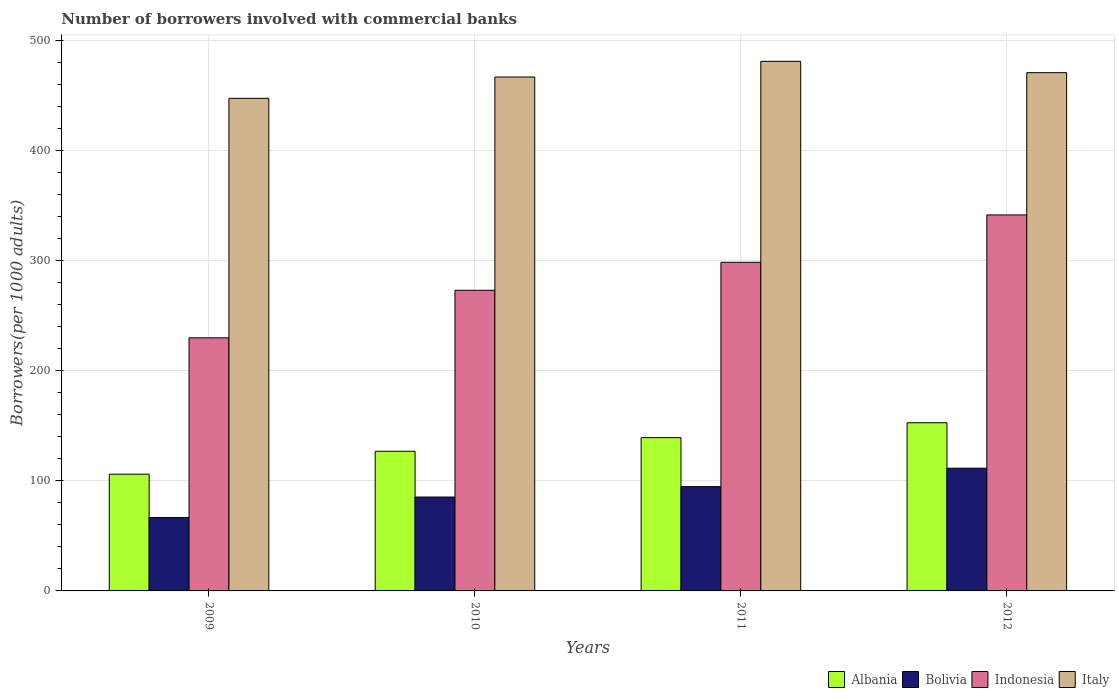How many different coloured bars are there?
Offer a very short reply. 4. Are the number of bars per tick equal to the number of legend labels?
Keep it short and to the point. Yes. Are the number of bars on each tick of the X-axis equal?
Your response must be concise. Yes. What is the label of the 1st group of bars from the left?
Provide a succinct answer. 2009. In how many cases, is the number of bars for a given year not equal to the number of legend labels?
Give a very brief answer. 0. What is the number of borrowers involved with commercial banks in Indonesia in 2010?
Make the answer very short. 273.1. Across all years, what is the maximum number of borrowers involved with commercial banks in Bolivia?
Provide a short and direct response. 111.49. Across all years, what is the minimum number of borrowers involved with commercial banks in Italy?
Provide a succinct answer. 447.49. In which year was the number of borrowers involved with commercial banks in Bolivia maximum?
Your answer should be very brief. 2012. What is the total number of borrowers involved with commercial banks in Bolivia in the graph?
Offer a terse response. 358.18. What is the difference between the number of borrowers involved with commercial banks in Indonesia in 2011 and that in 2012?
Provide a short and direct response. -43.06. What is the difference between the number of borrowers involved with commercial banks in Indonesia in 2011 and the number of borrowers involved with commercial banks in Bolivia in 2012?
Give a very brief answer. 187.02. What is the average number of borrowers involved with commercial banks in Italy per year?
Your response must be concise. 466.55. In the year 2012, what is the difference between the number of borrowers involved with commercial banks in Italy and number of borrowers involved with commercial banks in Bolivia?
Offer a very short reply. 359.3. In how many years, is the number of borrowers involved with commercial banks in Italy greater than 40?
Keep it short and to the point. 4. What is the ratio of the number of borrowers involved with commercial banks in Bolivia in 2009 to that in 2011?
Provide a succinct answer. 0.7. Is the number of borrowers involved with commercial banks in Bolivia in 2009 less than that in 2011?
Provide a succinct answer. Yes. What is the difference between the highest and the second highest number of borrowers involved with commercial banks in Italy?
Make the answer very short. 10.28. What is the difference between the highest and the lowest number of borrowers involved with commercial banks in Bolivia?
Your answer should be very brief. 44.81. Is it the case that in every year, the sum of the number of borrowers involved with commercial banks in Italy and number of borrowers involved with commercial banks in Bolivia is greater than the sum of number of borrowers involved with commercial banks in Albania and number of borrowers involved with commercial banks in Indonesia?
Offer a very short reply. Yes. What does the 2nd bar from the left in 2009 represents?
Give a very brief answer. Bolivia. What does the 1st bar from the right in 2012 represents?
Offer a terse response. Italy. Is it the case that in every year, the sum of the number of borrowers involved with commercial banks in Indonesia and number of borrowers involved with commercial banks in Italy is greater than the number of borrowers involved with commercial banks in Bolivia?
Your answer should be very brief. Yes. How many bars are there?
Provide a succinct answer. 16. Are the values on the major ticks of Y-axis written in scientific E-notation?
Your response must be concise. No. Does the graph contain any zero values?
Provide a succinct answer. No. Does the graph contain grids?
Your answer should be very brief. Yes. Where does the legend appear in the graph?
Give a very brief answer. Bottom right. How many legend labels are there?
Make the answer very short. 4. What is the title of the graph?
Ensure brevity in your answer.  Number of borrowers involved with commercial banks. Does "St. Kitts and Nevis" appear as one of the legend labels in the graph?
Your answer should be very brief. No. What is the label or title of the X-axis?
Your response must be concise. Years. What is the label or title of the Y-axis?
Your answer should be very brief. Borrowers(per 1000 adults). What is the Borrowers(per 1000 adults) of Albania in 2009?
Keep it short and to the point. 106.05. What is the Borrowers(per 1000 adults) in Bolivia in 2009?
Provide a short and direct response. 66.68. What is the Borrowers(per 1000 adults) in Indonesia in 2009?
Keep it short and to the point. 229.92. What is the Borrowers(per 1000 adults) of Italy in 2009?
Your answer should be very brief. 447.49. What is the Borrowers(per 1000 adults) of Albania in 2010?
Provide a short and direct response. 126.87. What is the Borrowers(per 1000 adults) of Bolivia in 2010?
Ensure brevity in your answer.  85.29. What is the Borrowers(per 1000 adults) in Indonesia in 2010?
Your response must be concise. 273.1. What is the Borrowers(per 1000 adults) of Italy in 2010?
Give a very brief answer. 466.85. What is the Borrowers(per 1000 adults) in Albania in 2011?
Offer a terse response. 139.27. What is the Borrowers(per 1000 adults) of Bolivia in 2011?
Offer a terse response. 94.73. What is the Borrowers(per 1000 adults) in Indonesia in 2011?
Keep it short and to the point. 298.51. What is the Borrowers(per 1000 adults) in Italy in 2011?
Offer a terse response. 481.07. What is the Borrowers(per 1000 adults) of Albania in 2012?
Keep it short and to the point. 152.78. What is the Borrowers(per 1000 adults) in Bolivia in 2012?
Keep it short and to the point. 111.49. What is the Borrowers(per 1000 adults) of Indonesia in 2012?
Provide a short and direct response. 341.57. What is the Borrowers(per 1000 adults) in Italy in 2012?
Your answer should be very brief. 470.79. Across all years, what is the maximum Borrowers(per 1000 adults) of Albania?
Your answer should be very brief. 152.78. Across all years, what is the maximum Borrowers(per 1000 adults) of Bolivia?
Give a very brief answer. 111.49. Across all years, what is the maximum Borrowers(per 1000 adults) in Indonesia?
Ensure brevity in your answer.  341.57. Across all years, what is the maximum Borrowers(per 1000 adults) in Italy?
Your answer should be compact. 481.07. Across all years, what is the minimum Borrowers(per 1000 adults) in Albania?
Keep it short and to the point. 106.05. Across all years, what is the minimum Borrowers(per 1000 adults) of Bolivia?
Offer a terse response. 66.68. Across all years, what is the minimum Borrowers(per 1000 adults) in Indonesia?
Your answer should be compact. 229.92. Across all years, what is the minimum Borrowers(per 1000 adults) in Italy?
Offer a terse response. 447.49. What is the total Borrowers(per 1000 adults) in Albania in the graph?
Offer a terse response. 524.96. What is the total Borrowers(per 1000 adults) in Bolivia in the graph?
Ensure brevity in your answer.  358.18. What is the total Borrowers(per 1000 adults) of Indonesia in the graph?
Your answer should be very brief. 1143.09. What is the total Borrowers(per 1000 adults) in Italy in the graph?
Offer a terse response. 1866.2. What is the difference between the Borrowers(per 1000 adults) in Albania in 2009 and that in 2010?
Your answer should be very brief. -20.82. What is the difference between the Borrowers(per 1000 adults) in Bolivia in 2009 and that in 2010?
Your answer should be compact. -18.61. What is the difference between the Borrowers(per 1000 adults) in Indonesia in 2009 and that in 2010?
Your answer should be very brief. -43.19. What is the difference between the Borrowers(per 1000 adults) of Italy in 2009 and that in 2010?
Give a very brief answer. -19.36. What is the difference between the Borrowers(per 1000 adults) in Albania in 2009 and that in 2011?
Your answer should be compact. -33.22. What is the difference between the Borrowers(per 1000 adults) in Bolivia in 2009 and that in 2011?
Your response must be concise. -28.05. What is the difference between the Borrowers(per 1000 adults) of Indonesia in 2009 and that in 2011?
Offer a terse response. -68.59. What is the difference between the Borrowers(per 1000 adults) of Italy in 2009 and that in 2011?
Offer a very short reply. -33.58. What is the difference between the Borrowers(per 1000 adults) of Albania in 2009 and that in 2012?
Ensure brevity in your answer.  -46.73. What is the difference between the Borrowers(per 1000 adults) of Bolivia in 2009 and that in 2012?
Offer a terse response. -44.81. What is the difference between the Borrowers(per 1000 adults) in Indonesia in 2009 and that in 2012?
Provide a succinct answer. -111.65. What is the difference between the Borrowers(per 1000 adults) of Italy in 2009 and that in 2012?
Your response must be concise. -23.3. What is the difference between the Borrowers(per 1000 adults) in Albania in 2010 and that in 2011?
Provide a succinct answer. -12.4. What is the difference between the Borrowers(per 1000 adults) in Bolivia in 2010 and that in 2011?
Ensure brevity in your answer.  -9.45. What is the difference between the Borrowers(per 1000 adults) in Indonesia in 2010 and that in 2011?
Ensure brevity in your answer.  -25.4. What is the difference between the Borrowers(per 1000 adults) of Italy in 2010 and that in 2011?
Ensure brevity in your answer.  -14.22. What is the difference between the Borrowers(per 1000 adults) in Albania in 2010 and that in 2012?
Your response must be concise. -25.91. What is the difference between the Borrowers(per 1000 adults) in Bolivia in 2010 and that in 2012?
Ensure brevity in your answer.  -26.2. What is the difference between the Borrowers(per 1000 adults) of Indonesia in 2010 and that in 2012?
Keep it short and to the point. -68.47. What is the difference between the Borrowers(per 1000 adults) of Italy in 2010 and that in 2012?
Offer a terse response. -3.94. What is the difference between the Borrowers(per 1000 adults) in Albania in 2011 and that in 2012?
Offer a terse response. -13.51. What is the difference between the Borrowers(per 1000 adults) in Bolivia in 2011 and that in 2012?
Your answer should be very brief. -16.75. What is the difference between the Borrowers(per 1000 adults) in Indonesia in 2011 and that in 2012?
Keep it short and to the point. -43.06. What is the difference between the Borrowers(per 1000 adults) of Italy in 2011 and that in 2012?
Offer a terse response. 10.28. What is the difference between the Borrowers(per 1000 adults) of Albania in 2009 and the Borrowers(per 1000 adults) of Bolivia in 2010?
Make the answer very short. 20.76. What is the difference between the Borrowers(per 1000 adults) in Albania in 2009 and the Borrowers(per 1000 adults) in Indonesia in 2010?
Your response must be concise. -167.05. What is the difference between the Borrowers(per 1000 adults) in Albania in 2009 and the Borrowers(per 1000 adults) in Italy in 2010?
Offer a terse response. -360.8. What is the difference between the Borrowers(per 1000 adults) of Bolivia in 2009 and the Borrowers(per 1000 adults) of Indonesia in 2010?
Offer a very short reply. -206.42. What is the difference between the Borrowers(per 1000 adults) in Bolivia in 2009 and the Borrowers(per 1000 adults) in Italy in 2010?
Your answer should be very brief. -400.17. What is the difference between the Borrowers(per 1000 adults) in Indonesia in 2009 and the Borrowers(per 1000 adults) in Italy in 2010?
Make the answer very short. -236.93. What is the difference between the Borrowers(per 1000 adults) of Albania in 2009 and the Borrowers(per 1000 adults) of Bolivia in 2011?
Keep it short and to the point. 11.31. What is the difference between the Borrowers(per 1000 adults) in Albania in 2009 and the Borrowers(per 1000 adults) in Indonesia in 2011?
Your response must be concise. -192.46. What is the difference between the Borrowers(per 1000 adults) in Albania in 2009 and the Borrowers(per 1000 adults) in Italy in 2011?
Ensure brevity in your answer.  -375.02. What is the difference between the Borrowers(per 1000 adults) in Bolivia in 2009 and the Borrowers(per 1000 adults) in Indonesia in 2011?
Offer a very short reply. -231.83. What is the difference between the Borrowers(per 1000 adults) of Bolivia in 2009 and the Borrowers(per 1000 adults) of Italy in 2011?
Provide a succinct answer. -414.39. What is the difference between the Borrowers(per 1000 adults) of Indonesia in 2009 and the Borrowers(per 1000 adults) of Italy in 2011?
Keep it short and to the point. -251.15. What is the difference between the Borrowers(per 1000 adults) of Albania in 2009 and the Borrowers(per 1000 adults) of Bolivia in 2012?
Your answer should be compact. -5.44. What is the difference between the Borrowers(per 1000 adults) in Albania in 2009 and the Borrowers(per 1000 adults) in Indonesia in 2012?
Provide a succinct answer. -235.52. What is the difference between the Borrowers(per 1000 adults) in Albania in 2009 and the Borrowers(per 1000 adults) in Italy in 2012?
Your answer should be very brief. -364.74. What is the difference between the Borrowers(per 1000 adults) of Bolivia in 2009 and the Borrowers(per 1000 adults) of Indonesia in 2012?
Make the answer very short. -274.89. What is the difference between the Borrowers(per 1000 adults) of Bolivia in 2009 and the Borrowers(per 1000 adults) of Italy in 2012?
Your answer should be compact. -404.11. What is the difference between the Borrowers(per 1000 adults) in Indonesia in 2009 and the Borrowers(per 1000 adults) in Italy in 2012?
Your answer should be compact. -240.87. What is the difference between the Borrowers(per 1000 adults) of Albania in 2010 and the Borrowers(per 1000 adults) of Bolivia in 2011?
Make the answer very short. 32.13. What is the difference between the Borrowers(per 1000 adults) in Albania in 2010 and the Borrowers(per 1000 adults) in Indonesia in 2011?
Offer a terse response. -171.64. What is the difference between the Borrowers(per 1000 adults) of Albania in 2010 and the Borrowers(per 1000 adults) of Italy in 2011?
Give a very brief answer. -354.2. What is the difference between the Borrowers(per 1000 adults) of Bolivia in 2010 and the Borrowers(per 1000 adults) of Indonesia in 2011?
Your answer should be compact. -213.22. What is the difference between the Borrowers(per 1000 adults) in Bolivia in 2010 and the Borrowers(per 1000 adults) in Italy in 2011?
Provide a succinct answer. -395.78. What is the difference between the Borrowers(per 1000 adults) in Indonesia in 2010 and the Borrowers(per 1000 adults) in Italy in 2011?
Keep it short and to the point. -207.97. What is the difference between the Borrowers(per 1000 adults) in Albania in 2010 and the Borrowers(per 1000 adults) in Bolivia in 2012?
Provide a short and direct response. 15.38. What is the difference between the Borrowers(per 1000 adults) of Albania in 2010 and the Borrowers(per 1000 adults) of Indonesia in 2012?
Provide a short and direct response. -214.7. What is the difference between the Borrowers(per 1000 adults) in Albania in 2010 and the Borrowers(per 1000 adults) in Italy in 2012?
Give a very brief answer. -343.92. What is the difference between the Borrowers(per 1000 adults) of Bolivia in 2010 and the Borrowers(per 1000 adults) of Indonesia in 2012?
Your answer should be compact. -256.28. What is the difference between the Borrowers(per 1000 adults) in Bolivia in 2010 and the Borrowers(per 1000 adults) in Italy in 2012?
Ensure brevity in your answer.  -385.5. What is the difference between the Borrowers(per 1000 adults) in Indonesia in 2010 and the Borrowers(per 1000 adults) in Italy in 2012?
Your response must be concise. -197.69. What is the difference between the Borrowers(per 1000 adults) of Albania in 2011 and the Borrowers(per 1000 adults) of Bolivia in 2012?
Ensure brevity in your answer.  27.78. What is the difference between the Borrowers(per 1000 adults) of Albania in 2011 and the Borrowers(per 1000 adults) of Indonesia in 2012?
Offer a very short reply. -202.3. What is the difference between the Borrowers(per 1000 adults) in Albania in 2011 and the Borrowers(per 1000 adults) in Italy in 2012?
Keep it short and to the point. -331.52. What is the difference between the Borrowers(per 1000 adults) in Bolivia in 2011 and the Borrowers(per 1000 adults) in Indonesia in 2012?
Offer a very short reply. -246.84. What is the difference between the Borrowers(per 1000 adults) in Bolivia in 2011 and the Borrowers(per 1000 adults) in Italy in 2012?
Ensure brevity in your answer.  -376.06. What is the difference between the Borrowers(per 1000 adults) in Indonesia in 2011 and the Borrowers(per 1000 adults) in Italy in 2012?
Your response must be concise. -172.28. What is the average Borrowers(per 1000 adults) in Albania per year?
Offer a terse response. 131.24. What is the average Borrowers(per 1000 adults) of Bolivia per year?
Keep it short and to the point. 89.55. What is the average Borrowers(per 1000 adults) in Indonesia per year?
Offer a very short reply. 285.77. What is the average Borrowers(per 1000 adults) of Italy per year?
Offer a very short reply. 466.55. In the year 2009, what is the difference between the Borrowers(per 1000 adults) in Albania and Borrowers(per 1000 adults) in Bolivia?
Give a very brief answer. 39.37. In the year 2009, what is the difference between the Borrowers(per 1000 adults) in Albania and Borrowers(per 1000 adults) in Indonesia?
Ensure brevity in your answer.  -123.87. In the year 2009, what is the difference between the Borrowers(per 1000 adults) in Albania and Borrowers(per 1000 adults) in Italy?
Give a very brief answer. -341.44. In the year 2009, what is the difference between the Borrowers(per 1000 adults) in Bolivia and Borrowers(per 1000 adults) in Indonesia?
Provide a short and direct response. -163.24. In the year 2009, what is the difference between the Borrowers(per 1000 adults) in Bolivia and Borrowers(per 1000 adults) in Italy?
Give a very brief answer. -380.81. In the year 2009, what is the difference between the Borrowers(per 1000 adults) in Indonesia and Borrowers(per 1000 adults) in Italy?
Offer a terse response. -217.57. In the year 2010, what is the difference between the Borrowers(per 1000 adults) in Albania and Borrowers(per 1000 adults) in Bolivia?
Offer a very short reply. 41.58. In the year 2010, what is the difference between the Borrowers(per 1000 adults) in Albania and Borrowers(per 1000 adults) in Indonesia?
Provide a short and direct response. -146.23. In the year 2010, what is the difference between the Borrowers(per 1000 adults) of Albania and Borrowers(per 1000 adults) of Italy?
Your response must be concise. -339.98. In the year 2010, what is the difference between the Borrowers(per 1000 adults) in Bolivia and Borrowers(per 1000 adults) in Indonesia?
Keep it short and to the point. -187.81. In the year 2010, what is the difference between the Borrowers(per 1000 adults) of Bolivia and Borrowers(per 1000 adults) of Italy?
Offer a very short reply. -381.56. In the year 2010, what is the difference between the Borrowers(per 1000 adults) of Indonesia and Borrowers(per 1000 adults) of Italy?
Give a very brief answer. -193.75. In the year 2011, what is the difference between the Borrowers(per 1000 adults) of Albania and Borrowers(per 1000 adults) of Bolivia?
Offer a terse response. 44.53. In the year 2011, what is the difference between the Borrowers(per 1000 adults) in Albania and Borrowers(per 1000 adults) in Indonesia?
Your answer should be compact. -159.24. In the year 2011, what is the difference between the Borrowers(per 1000 adults) of Albania and Borrowers(per 1000 adults) of Italy?
Your response must be concise. -341.8. In the year 2011, what is the difference between the Borrowers(per 1000 adults) in Bolivia and Borrowers(per 1000 adults) in Indonesia?
Provide a short and direct response. -203.77. In the year 2011, what is the difference between the Borrowers(per 1000 adults) in Bolivia and Borrowers(per 1000 adults) in Italy?
Provide a short and direct response. -386.34. In the year 2011, what is the difference between the Borrowers(per 1000 adults) in Indonesia and Borrowers(per 1000 adults) in Italy?
Your answer should be compact. -182.56. In the year 2012, what is the difference between the Borrowers(per 1000 adults) of Albania and Borrowers(per 1000 adults) of Bolivia?
Offer a terse response. 41.29. In the year 2012, what is the difference between the Borrowers(per 1000 adults) of Albania and Borrowers(per 1000 adults) of Indonesia?
Ensure brevity in your answer.  -188.79. In the year 2012, what is the difference between the Borrowers(per 1000 adults) of Albania and Borrowers(per 1000 adults) of Italy?
Give a very brief answer. -318.01. In the year 2012, what is the difference between the Borrowers(per 1000 adults) of Bolivia and Borrowers(per 1000 adults) of Indonesia?
Your answer should be very brief. -230.08. In the year 2012, what is the difference between the Borrowers(per 1000 adults) in Bolivia and Borrowers(per 1000 adults) in Italy?
Ensure brevity in your answer.  -359.3. In the year 2012, what is the difference between the Borrowers(per 1000 adults) of Indonesia and Borrowers(per 1000 adults) of Italy?
Keep it short and to the point. -129.22. What is the ratio of the Borrowers(per 1000 adults) in Albania in 2009 to that in 2010?
Make the answer very short. 0.84. What is the ratio of the Borrowers(per 1000 adults) in Bolivia in 2009 to that in 2010?
Your answer should be very brief. 0.78. What is the ratio of the Borrowers(per 1000 adults) in Indonesia in 2009 to that in 2010?
Your response must be concise. 0.84. What is the ratio of the Borrowers(per 1000 adults) of Italy in 2009 to that in 2010?
Your answer should be compact. 0.96. What is the ratio of the Borrowers(per 1000 adults) of Albania in 2009 to that in 2011?
Ensure brevity in your answer.  0.76. What is the ratio of the Borrowers(per 1000 adults) in Bolivia in 2009 to that in 2011?
Make the answer very short. 0.7. What is the ratio of the Borrowers(per 1000 adults) of Indonesia in 2009 to that in 2011?
Provide a succinct answer. 0.77. What is the ratio of the Borrowers(per 1000 adults) in Italy in 2009 to that in 2011?
Your answer should be compact. 0.93. What is the ratio of the Borrowers(per 1000 adults) of Albania in 2009 to that in 2012?
Keep it short and to the point. 0.69. What is the ratio of the Borrowers(per 1000 adults) in Bolivia in 2009 to that in 2012?
Give a very brief answer. 0.6. What is the ratio of the Borrowers(per 1000 adults) in Indonesia in 2009 to that in 2012?
Your answer should be compact. 0.67. What is the ratio of the Borrowers(per 1000 adults) of Italy in 2009 to that in 2012?
Your answer should be very brief. 0.95. What is the ratio of the Borrowers(per 1000 adults) of Albania in 2010 to that in 2011?
Keep it short and to the point. 0.91. What is the ratio of the Borrowers(per 1000 adults) of Bolivia in 2010 to that in 2011?
Provide a succinct answer. 0.9. What is the ratio of the Borrowers(per 1000 adults) of Indonesia in 2010 to that in 2011?
Ensure brevity in your answer.  0.91. What is the ratio of the Borrowers(per 1000 adults) in Italy in 2010 to that in 2011?
Offer a terse response. 0.97. What is the ratio of the Borrowers(per 1000 adults) in Albania in 2010 to that in 2012?
Offer a very short reply. 0.83. What is the ratio of the Borrowers(per 1000 adults) of Bolivia in 2010 to that in 2012?
Offer a terse response. 0.77. What is the ratio of the Borrowers(per 1000 adults) of Indonesia in 2010 to that in 2012?
Make the answer very short. 0.8. What is the ratio of the Borrowers(per 1000 adults) of Albania in 2011 to that in 2012?
Provide a short and direct response. 0.91. What is the ratio of the Borrowers(per 1000 adults) in Bolivia in 2011 to that in 2012?
Your answer should be compact. 0.85. What is the ratio of the Borrowers(per 1000 adults) in Indonesia in 2011 to that in 2012?
Provide a short and direct response. 0.87. What is the ratio of the Borrowers(per 1000 adults) in Italy in 2011 to that in 2012?
Make the answer very short. 1.02. What is the difference between the highest and the second highest Borrowers(per 1000 adults) in Albania?
Your response must be concise. 13.51. What is the difference between the highest and the second highest Borrowers(per 1000 adults) of Bolivia?
Provide a short and direct response. 16.75. What is the difference between the highest and the second highest Borrowers(per 1000 adults) in Indonesia?
Offer a terse response. 43.06. What is the difference between the highest and the second highest Borrowers(per 1000 adults) of Italy?
Your answer should be compact. 10.28. What is the difference between the highest and the lowest Borrowers(per 1000 adults) of Albania?
Make the answer very short. 46.73. What is the difference between the highest and the lowest Borrowers(per 1000 adults) of Bolivia?
Give a very brief answer. 44.81. What is the difference between the highest and the lowest Borrowers(per 1000 adults) of Indonesia?
Offer a terse response. 111.65. What is the difference between the highest and the lowest Borrowers(per 1000 adults) in Italy?
Your answer should be very brief. 33.58. 